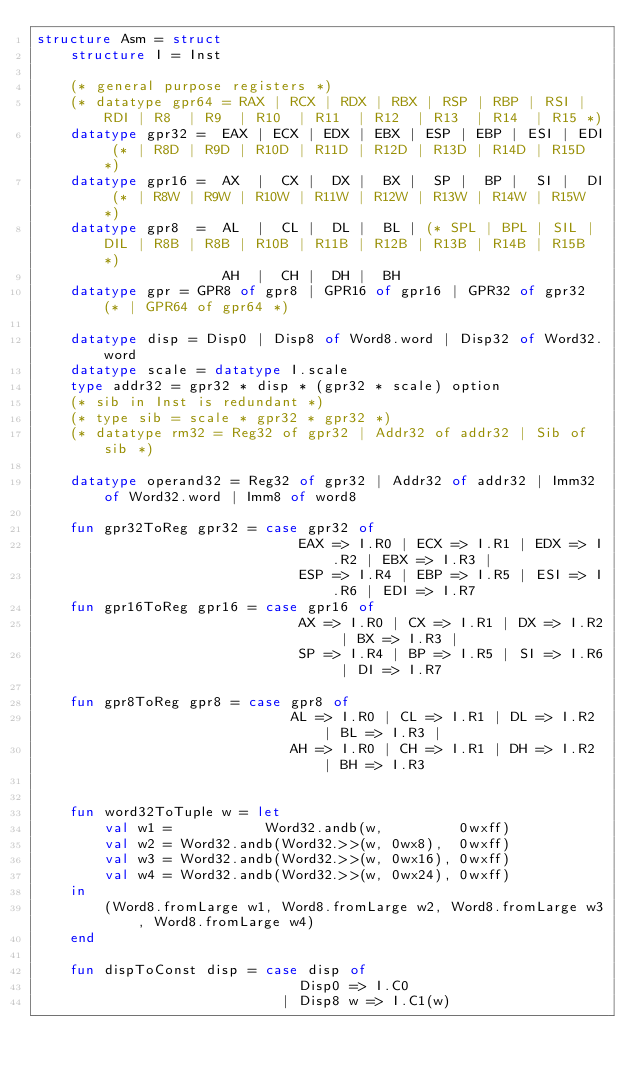<code> <loc_0><loc_0><loc_500><loc_500><_SML_>structure Asm = struct
    structure I = Inst

    (* general purpose registers *)
    (* datatype gpr64 = RAX | RCX | RDX | RBX | RSP | RBP | RSI | RDI | R8  | R9  | R10  | R11  | R12  | R13  | R14  | R15 *)
    datatype gpr32 =  EAX | ECX | EDX | EBX | ESP | EBP | ESI | EDI (* | R8D | R9D | R10D | R11D | R12D | R13D | R14D | R15D *)
    datatype gpr16 =  AX  |  CX |  DX |  BX |  SP |  BP |  SI |  DI (* | R8W | R9W | R10W | R11W | R12W | R13W | R14W | R15W *)
    datatype gpr8  =  AL  |  CL |  DL |  BL | (* SPL | BPL | SIL | DIL | R8B | R8B | R10B | R11B | R12B | R13B | R14B | R15B *)
                      AH  |  CH |  DH |  BH
    datatype gpr = GPR8 of gpr8 | GPR16 of gpr16 | GPR32 of gpr32 (* | GPR64 of gpr64 *)

    datatype disp = Disp0 | Disp8 of Word8.word | Disp32 of Word32.word
    datatype scale = datatype I.scale
    type addr32 = gpr32 * disp * (gpr32 * scale) option 
    (* sib in Inst is redundant *)
    (* type sib = scale * gpr32 * gpr32 *)
    (* datatype rm32 = Reg32 of gpr32 | Addr32 of addr32 | Sib of sib *)

    datatype operand32 = Reg32 of gpr32 | Addr32 of addr32 | Imm32 of Word32.word | Imm8 of word8

    fun gpr32ToReg gpr32 = case gpr32 of
                               EAX => I.R0 | ECX => I.R1 | EDX => I.R2 | EBX => I.R3 |
                               ESP => I.R4 | EBP => I.R5 | ESI => I.R6 | EDI => I.R7
    fun gpr16ToReg gpr16 = case gpr16 of
                               AX => I.R0 | CX => I.R1 | DX => I.R2 | BX => I.R3 |
                               SP => I.R4 | BP => I.R5 | SI => I.R6 | DI => I.R7

    fun gpr8ToReg gpr8 = case gpr8 of
                              AL => I.R0 | CL => I.R1 | DL => I.R2 | BL => I.R3 |
                              AH => I.R0 | CH => I.R1 | DH => I.R2 | BH => I.R3


    fun word32ToTuple w = let
        val w1 =           Word32.andb(w,         0wxff)
        val w2 = Word32.andb(Word32.>>(w, 0wx8),  0wxff)
        val w3 = Word32.andb(Word32.>>(w, 0wx16), 0wxff)
        val w4 = Word32.andb(Word32.>>(w, 0wx24), 0wxff)
    in
        (Word8.fromLarge w1, Word8.fromLarge w2, Word8.fromLarge w3, Word8.fromLarge w4)
    end

    fun dispToConst disp = case disp of
                               Disp0 => I.C0
                             | Disp8 w => I.C1(w)</code> 